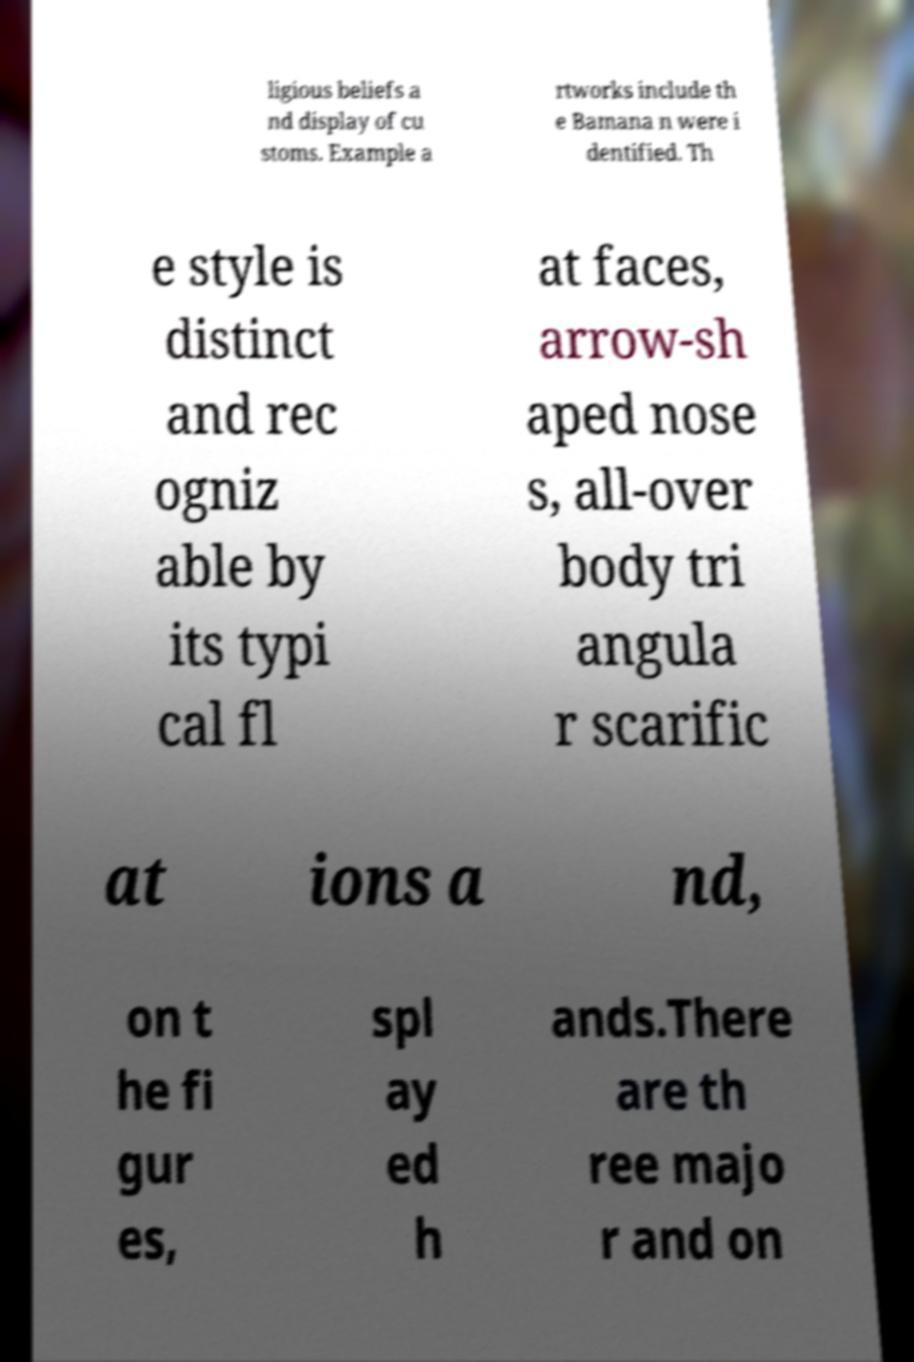Please identify and transcribe the text found in this image. ligious beliefs a nd display of cu stoms. Example a rtworks include th e Bamana n were i dentified. Th e style is distinct and rec ogniz able by its typi cal fl at faces, arrow-sh aped nose s, all-over body tri angula r scarific at ions a nd, on t he fi gur es, spl ay ed h ands.There are th ree majo r and on 